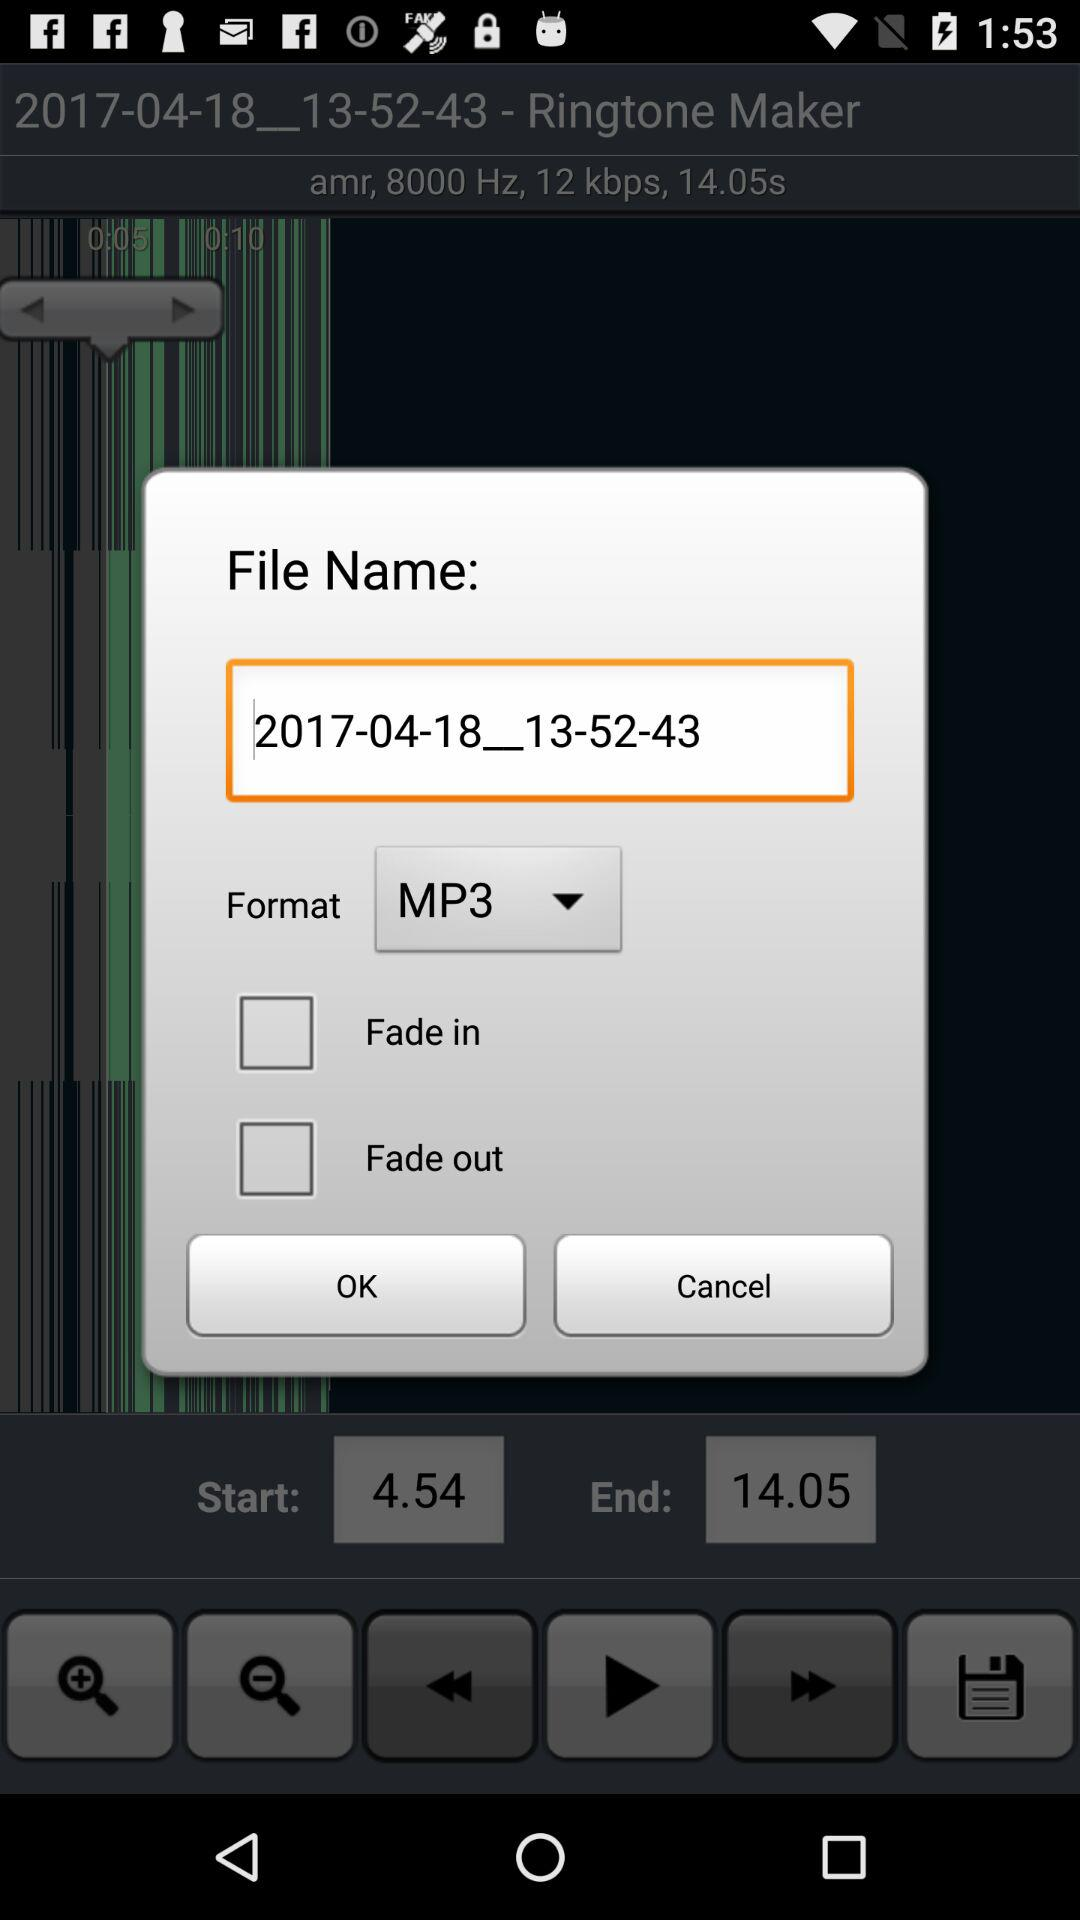How many more checkboxes are there for the fade out option than the fade in option?
Answer the question using a single word or phrase. 1 